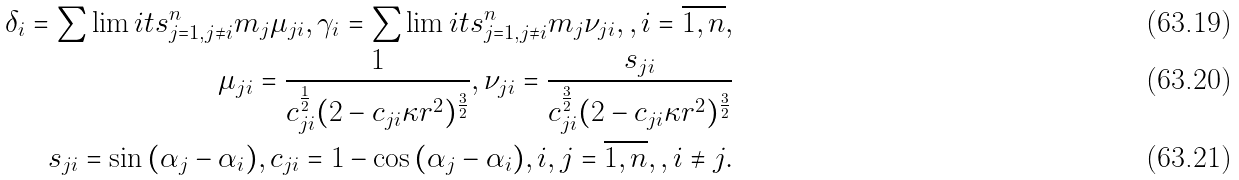<formula> <loc_0><loc_0><loc_500><loc_500>\delta _ { i } = \sum \lim i t s _ { j = 1 , j \neq i } ^ { n } m _ { j } \mu _ { j i } , \gamma _ { i } = \sum \lim i t s _ { j = 1 , j \neq i } ^ { n } m _ { j } \nu _ { j i } , , i = \overline { 1 , n } , \\ \mu _ { j i } = \frac { 1 } { c _ { j i } ^ { \frac { 1 } { 2 } } ( 2 - c _ { j i } \kappa r ^ { 2 } ) ^ { \frac { 3 } { 2 } } } , \nu _ { j i } = \frac { s _ { j i } } { c _ { j i } ^ { \frac { 3 } { 2 } } ( 2 - c _ { j i } \kappa r ^ { 2 } ) ^ { \frac { 3 } { 2 } } } \\ s _ { j i } = \sin { ( \alpha _ { j } - \alpha _ { i } ) } , c _ { j i } = 1 - \cos { ( \alpha _ { j } - \alpha _ { i } ) } , i , j = \overline { 1 , n } , , i \neq j .</formula> 